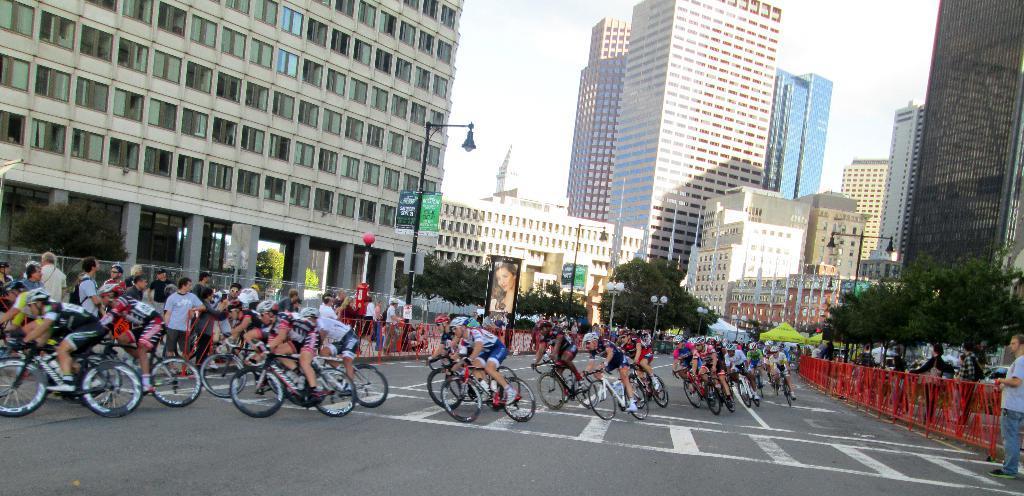Could you give a brief overview of what you see in this image? In the middle of the image few people are riding bicycles. Behind them few people are standing and watching. Bottom right side of the image there is a fencing and few people are standing and watching. Behind them there are some trees and buildings. Top of the image there are some clouds and sky. Top left side of the image there is a pole. Behind the pole there is a buildings. 